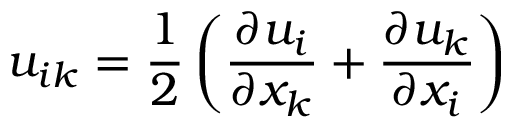<formula> <loc_0><loc_0><loc_500><loc_500>u _ { i k } = \frac { 1 } { 2 } \left ( \frac { \partial u _ { i } } { \partial x _ { k } } + \frac { \partial u _ { k } } { \partial x _ { i } } \right )</formula> 